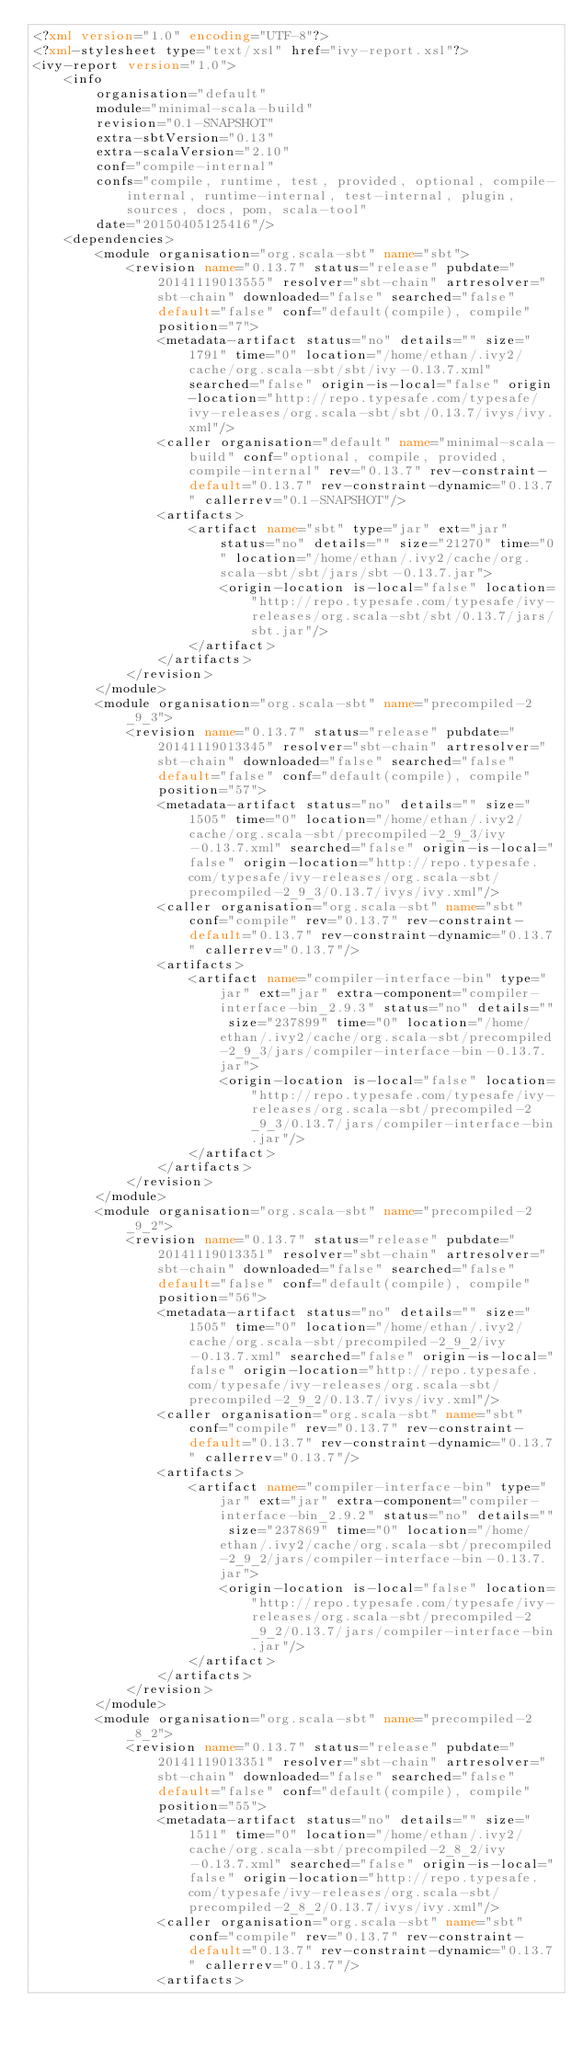<code> <loc_0><loc_0><loc_500><loc_500><_XML_><?xml version="1.0" encoding="UTF-8"?>
<?xml-stylesheet type="text/xsl" href="ivy-report.xsl"?>
<ivy-report version="1.0">
	<info
		organisation="default"
		module="minimal-scala-build"
		revision="0.1-SNAPSHOT"
		extra-sbtVersion="0.13"
		extra-scalaVersion="2.10"
		conf="compile-internal"
		confs="compile, runtime, test, provided, optional, compile-internal, runtime-internal, test-internal, plugin, sources, docs, pom, scala-tool"
		date="20150405125416"/>
	<dependencies>
		<module organisation="org.scala-sbt" name="sbt">
			<revision name="0.13.7" status="release" pubdate="20141119013555" resolver="sbt-chain" artresolver="sbt-chain" downloaded="false" searched="false" default="false" conf="default(compile), compile" position="7">
				<metadata-artifact status="no" details="" size="1791" time="0" location="/home/ethan/.ivy2/cache/org.scala-sbt/sbt/ivy-0.13.7.xml" searched="false" origin-is-local="false" origin-location="http://repo.typesafe.com/typesafe/ivy-releases/org.scala-sbt/sbt/0.13.7/ivys/ivy.xml"/>
				<caller organisation="default" name="minimal-scala-build" conf="optional, compile, provided, compile-internal" rev="0.13.7" rev-constraint-default="0.13.7" rev-constraint-dynamic="0.13.7" callerrev="0.1-SNAPSHOT"/>
				<artifacts>
					<artifact name="sbt" type="jar" ext="jar" status="no" details="" size="21270" time="0" location="/home/ethan/.ivy2/cache/org.scala-sbt/sbt/jars/sbt-0.13.7.jar">
						<origin-location is-local="false" location="http://repo.typesafe.com/typesafe/ivy-releases/org.scala-sbt/sbt/0.13.7/jars/sbt.jar"/>
					</artifact>
				</artifacts>
			</revision>
		</module>
		<module organisation="org.scala-sbt" name="precompiled-2_9_3">
			<revision name="0.13.7" status="release" pubdate="20141119013345" resolver="sbt-chain" artresolver="sbt-chain" downloaded="false" searched="false" default="false" conf="default(compile), compile" position="57">
				<metadata-artifact status="no" details="" size="1505" time="0" location="/home/ethan/.ivy2/cache/org.scala-sbt/precompiled-2_9_3/ivy-0.13.7.xml" searched="false" origin-is-local="false" origin-location="http://repo.typesafe.com/typesafe/ivy-releases/org.scala-sbt/precompiled-2_9_3/0.13.7/ivys/ivy.xml"/>
				<caller organisation="org.scala-sbt" name="sbt" conf="compile" rev="0.13.7" rev-constraint-default="0.13.7" rev-constraint-dynamic="0.13.7" callerrev="0.13.7"/>
				<artifacts>
					<artifact name="compiler-interface-bin" type="jar" ext="jar" extra-component="compiler-interface-bin_2.9.3" status="no" details="" size="237899" time="0" location="/home/ethan/.ivy2/cache/org.scala-sbt/precompiled-2_9_3/jars/compiler-interface-bin-0.13.7.jar">
						<origin-location is-local="false" location="http://repo.typesafe.com/typesafe/ivy-releases/org.scala-sbt/precompiled-2_9_3/0.13.7/jars/compiler-interface-bin.jar"/>
					</artifact>
				</artifacts>
			</revision>
		</module>
		<module organisation="org.scala-sbt" name="precompiled-2_9_2">
			<revision name="0.13.7" status="release" pubdate="20141119013351" resolver="sbt-chain" artresolver="sbt-chain" downloaded="false" searched="false" default="false" conf="default(compile), compile" position="56">
				<metadata-artifact status="no" details="" size="1505" time="0" location="/home/ethan/.ivy2/cache/org.scala-sbt/precompiled-2_9_2/ivy-0.13.7.xml" searched="false" origin-is-local="false" origin-location="http://repo.typesafe.com/typesafe/ivy-releases/org.scala-sbt/precompiled-2_9_2/0.13.7/ivys/ivy.xml"/>
				<caller organisation="org.scala-sbt" name="sbt" conf="compile" rev="0.13.7" rev-constraint-default="0.13.7" rev-constraint-dynamic="0.13.7" callerrev="0.13.7"/>
				<artifacts>
					<artifact name="compiler-interface-bin" type="jar" ext="jar" extra-component="compiler-interface-bin_2.9.2" status="no" details="" size="237869" time="0" location="/home/ethan/.ivy2/cache/org.scala-sbt/precompiled-2_9_2/jars/compiler-interface-bin-0.13.7.jar">
						<origin-location is-local="false" location="http://repo.typesafe.com/typesafe/ivy-releases/org.scala-sbt/precompiled-2_9_2/0.13.7/jars/compiler-interface-bin.jar"/>
					</artifact>
				</artifacts>
			</revision>
		</module>
		<module organisation="org.scala-sbt" name="precompiled-2_8_2">
			<revision name="0.13.7" status="release" pubdate="20141119013351" resolver="sbt-chain" artresolver="sbt-chain" downloaded="false" searched="false" default="false" conf="default(compile), compile" position="55">
				<metadata-artifact status="no" details="" size="1511" time="0" location="/home/ethan/.ivy2/cache/org.scala-sbt/precompiled-2_8_2/ivy-0.13.7.xml" searched="false" origin-is-local="false" origin-location="http://repo.typesafe.com/typesafe/ivy-releases/org.scala-sbt/precompiled-2_8_2/0.13.7/ivys/ivy.xml"/>
				<caller organisation="org.scala-sbt" name="sbt" conf="compile" rev="0.13.7" rev-constraint-default="0.13.7" rev-constraint-dynamic="0.13.7" callerrev="0.13.7"/>
				<artifacts></code> 